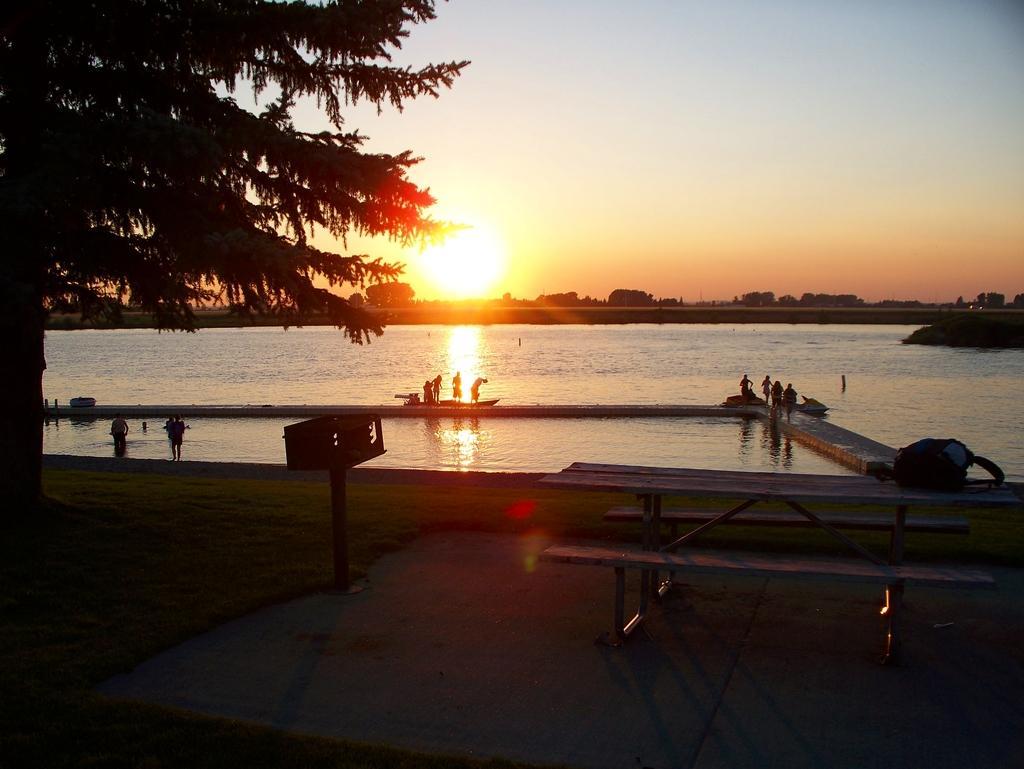Describe this image in one or two sentences. In this image on the right side there is a bench and pole and some box, and in the background there is a beach and some persons and ships. On the right side there is a tree, at the bottom there is a walkway and in the background there are some buildings. At the top there is sky and in the center there is sun. 